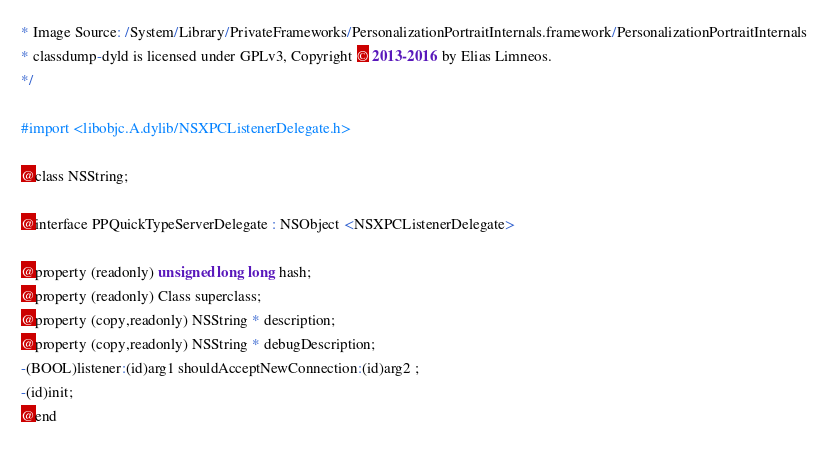Convert code to text. <code><loc_0><loc_0><loc_500><loc_500><_C_>* Image Source: /System/Library/PrivateFrameworks/PersonalizationPortraitInternals.framework/PersonalizationPortraitInternals
* classdump-dyld is licensed under GPLv3, Copyright © 2013-2016 by Elias Limneos.
*/

#import <libobjc.A.dylib/NSXPCListenerDelegate.h>

@class NSString;

@interface PPQuickTypeServerDelegate : NSObject <NSXPCListenerDelegate>

@property (readonly) unsigned long long hash; 
@property (readonly) Class superclass; 
@property (copy,readonly) NSString * description; 
@property (copy,readonly) NSString * debugDescription; 
-(BOOL)listener:(id)arg1 shouldAcceptNewConnection:(id)arg2 ;
-(id)init;
@end

</code> 